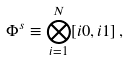Convert formula to latex. <formula><loc_0><loc_0><loc_500><loc_500>\Phi ^ { s } \equiv \bigotimes _ { i = 1 } ^ { N } [ i 0 , i 1 ] \, ,</formula> 